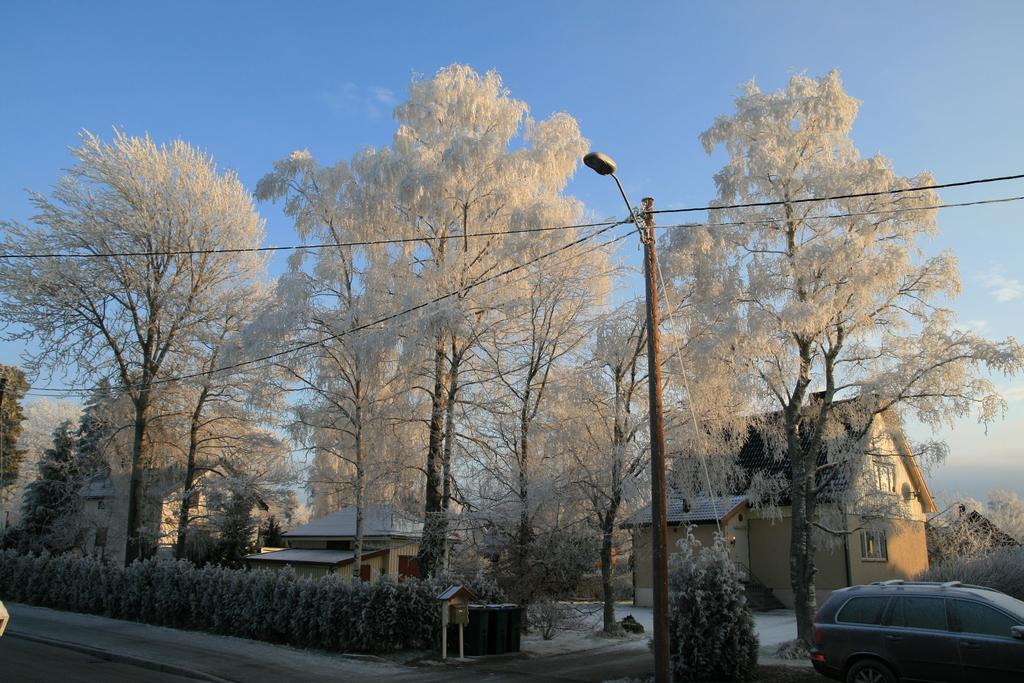Can you describe this image briefly? In this image I can see a car on the road. Background I can see few dried trees, a light pole and sky in blue color. 